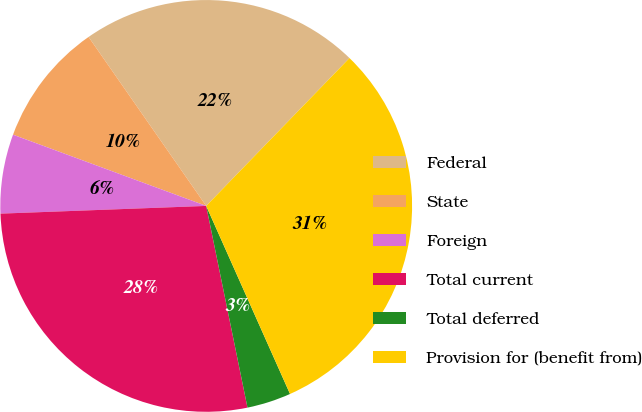Convert chart to OTSL. <chart><loc_0><loc_0><loc_500><loc_500><pie_chart><fcel>Federal<fcel>State<fcel>Foreign<fcel>Total current<fcel>Total deferred<fcel>Provision for (benefit from)<nl><fcel>21.93%<fcel>9.7%<fcel>6.22%<fcel>27.62%<fcel>3.46%<fcel>31.08%<nl></chart> 